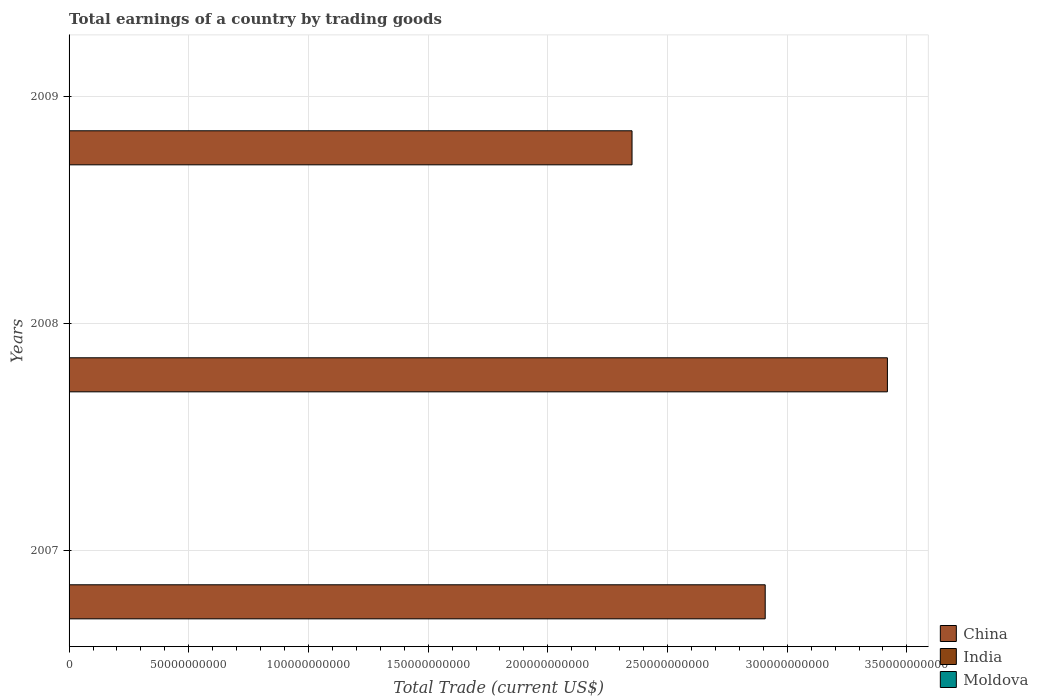How many different coloured bars are there?
Offer a terse response. 1. Are the number of bars per tick equal to the number of legend labels?
Offer a terse response. No. Are the number of bars on each tick of the Y-axis equal?
Make the answer very short. Yes. How many bars are there on the 3rd tick from the top?
Ensure brevity in your answer.  1. What is the total earnings in India in 2008?
Provide a succinct answer. 0. Across all years, what is the maximum total earnings in China?
Provide a short and direct response. 3.42e+11. Across all years, what is the minimum total earnings in India?
Ensure brevity in your answer.  0. What is the total total earnings in China in the graph?
Offer a very short reply. 8.68e+11. What is the difference between the total earnings in China in 2007 and that in 2008?
Offer a very short reply. -5.10e+1. What is the difference between the total earnings in China in 2008 and the total earnings in India in 2007?
Give a very brief answer. 3.42e+11. What is the average total earnings in China per year?
Offer a terse response. 2.89e+11. In how many years, is the total earnings in Moldova greater than 190000000000 US$?
Keep it short and to the point. 0. What is the ratio of the total earnings in China in 2007 to that in 2008?
Make the answer very short. 0.85. What is the difference between the highest and the second highest total earnings in China?
Your answer should be compact. 5.10e+1. What is the difference between the highest and the lowest total earnings in China?
Make the answer very short. 1.07e+11. In how many years, is the total earnings in India greater than the average total earnings in India taken over all years?
Give a very brief answer. 0. Is the sum of the total earnings in China in 2008 and 2009 greater than the maximum total earnings in India across all years?
Ensure brevity in your answer.  Yes. Is it the case that in every year, the sum of the total earnings in China and total earnings in Moldova is greater than the total earnings in India?
Give a very brief answer. Yes. How many bars are there?
Ensure brevity in your answer.  3. What is the difference between two consecutive major ticks on the X-axis?
Your response must be concise. 5.00e+1. Are the values on the major ticks of X-axis written in scientific E-notation?
Give a very brief answer. No. Does the graph contain any zero values?
Provide a short and direct response. Yes. Does the graph contain grids?
Provide a short and direct response. Yes. Where does the legend appear in the graph?
Your answer should be compact. Bottom right. How many legend labels are there?
Provide a succinct answer. 3. How are the legend labels stacked?
Make the answer very short. Vertical. What is the title of the graph?
Provide a short and direct response. Total earnings of a country by trading goods. Does "Palau" appear as one of the legend labels in the graph?
Provide a succinct answer. No. What is the label or title of the X-axis?
Offer a very short reply. Total Trade (current US$). What is the label or title of the Y-axis?
Provide a succinct answer. Years. What is the Total Trade (current US$) of China in 2007?
Offer a terse response. 2.91e+11. What is the Total Trade (current US$) of India in 2007?
Make the answer very short. 0. What is the Total Trade (current US$) in China in 2008?
Make the answer very short. 3.42e+11. What is the Total Trade (current US$) of China in 2009?
Make the answer very short. 2.35e+11. What is the Total Trade (current US$) of India in 2009?
Your response must be concise. 0. What is the Total Trade (current US$) in Moldova in 2009?
Provide a succinct answer. 0. Across all years, what is the maximum Total Trade (current US$) in China?
Your response must be concise. 3.42e+11. Across all years, what is the minimum Total Trade (current US$) of China?
Keep it short and to the point. 2.35e+11. What is the total Total Trade (current US$) of China in the graph?
Offer a very short reply. 8.68e+11. What is the total Total Trade (current US$) in India in the graph?
Make the answer very short. 0. What is the total Total Trade (current US$) of Moldova in the graph?
Ensure brevity in your answer.  0. What is the difference between the Total Trade (current US$) of China in 2007 and that in 2008?
Your answer should be very brief. -5.10e+1. What is the difference between the Total Trade (current US$) in China in 2007 and that in 2009?
Provide a succinct answer. 5.56e+1. What is the difference between the Total Trade (current US$) of China in 2008 and that in 2009?
Your answer should be very brief. 1.07e+11. What is the average Total Trade (current US$) in China per year?
Your answer should be very brief. 2.89e+11. What is the ratio of the Total Trade (current US$) of China in 2007 to that in 2008?
Ensure brevity in your answer.  0.85. What is the ratio of the Total Trade (current US$) in China in 2007 to that in 2009?
Make the answer very short. 1.24. What is the ratio of the Total Trade (current US$) in China in 2008 to that in 2009?
Keep it short and to the point. 1.45. What is the difference between the highest and the second highest Total Trade (current US$) in China?
Offer a very short reply. 5.10e+1. What is the difference between the highest and the lowest Total Trade (current US$) in China?
Provide a succinct answer. 1.07e+11. 